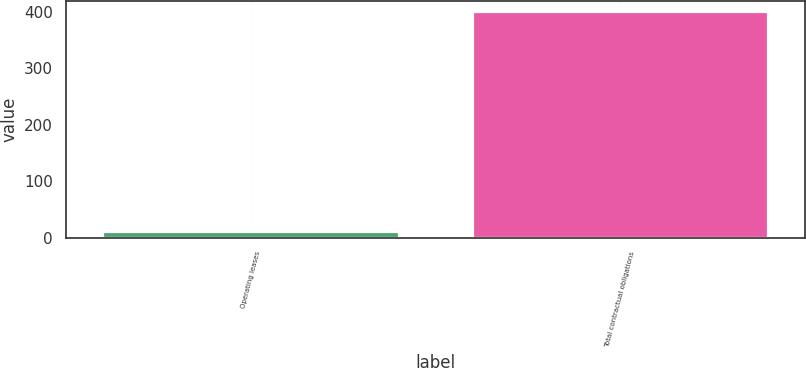Convert chart. <chart><loc_0><loc_0><loc_500><loc_500><bar_chart><fcel>Operating leases<fcel>Total contractual obligations<nl><fcel>9.2<fcel>400<nl></chart> 